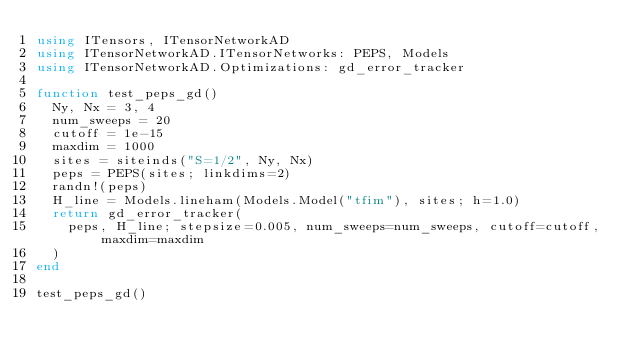Convert code to text. <code><loc_0><loc_0><loc_500><loc_500><_Julia_>using ITensors, ITensorNetworkAD
using ITensorNetworkAD.ITensorNetworks: PEPS, Models
using ITensorNetworkAD.Optimizations: gd_error_tracker

function test_peps_gd()
  Ny, Nx = 3, 4
  num_sweeps = 20
  cutoff = 1e-15
  maxdim = 1000
  sites = siteinds("S=1/2", Ny, Nx)
  peps = PEPS(sites; linkdims=2)
  randn!(peps)
  H_line = Models.lineham(Models.Model("tfim"), sites; h=1.0)
  return gd_error_tracker(
    peps, H_line; stepsize=0.005, num_sweeps=num_sweeps, cutoff=cutoff, maxdim=maxdim
  )
end

test_peps_gd()
</code> 